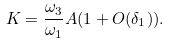Convert formula to latex. <formula><loc_0><loc_0><loc_500><loc_500>K = \frac { \omega _ { 3 } } { \omega _ { 1 } } A ( 1 + O ( \delta _ { 1 } ) ) .</formula> 